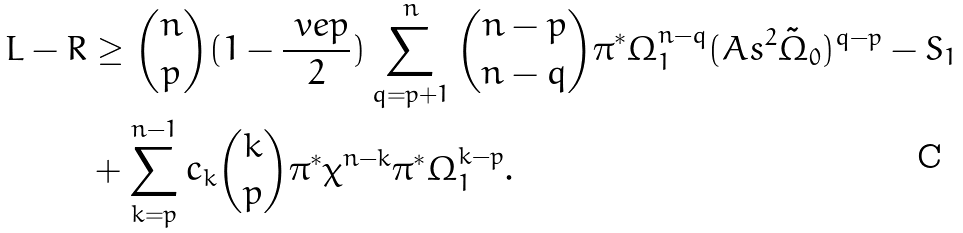Convert formula to latex. <formula><loc_0><loc_0><loc_500><loc_500>L - R & \geq { n \choose p } ( 1 - \frac { \ v e p } { 2 } ) \sum _ { q = p + 1 } ^ { n } { n - p \choose n - q } \pi ^ { * } \Omega _ { 1 } ^ { n - q } ( A s ^ { 2 } \tilde { \Omega } _ { 0 } ) ^ { q - p } - S _ { 1 } \\ & + \sum _ { k = p } ^ { n - 1 } c _ { k } { k \choose p } \pi ^ { * } \chi ^ { n - k } \pi ^ { * } \Omega _ { 1 } ^ { k - p } .</formula> 